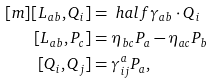Convert formula to latex. <formula><loc_0><loc_0><loc_500><loc_500>[ m ] [ L _ { a b } , Q _ { i } ] & = \ h a l f \gamma _ { a b } \cdot Q _ { i } \\ [ L _ { a b } , P _ { c } ] & = \eta _ { b c } P _ { a } - \eta _ { a c } P _ { b } \\ [ Q _ { i } , Q _ { j } ] & = \gamma ^ { a } _ { i j } P _ { a } ,</formula> 